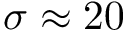<formula> <loc_0><loc_0><loc_500><loc_500>\sigma \approx 2 0</formula> 